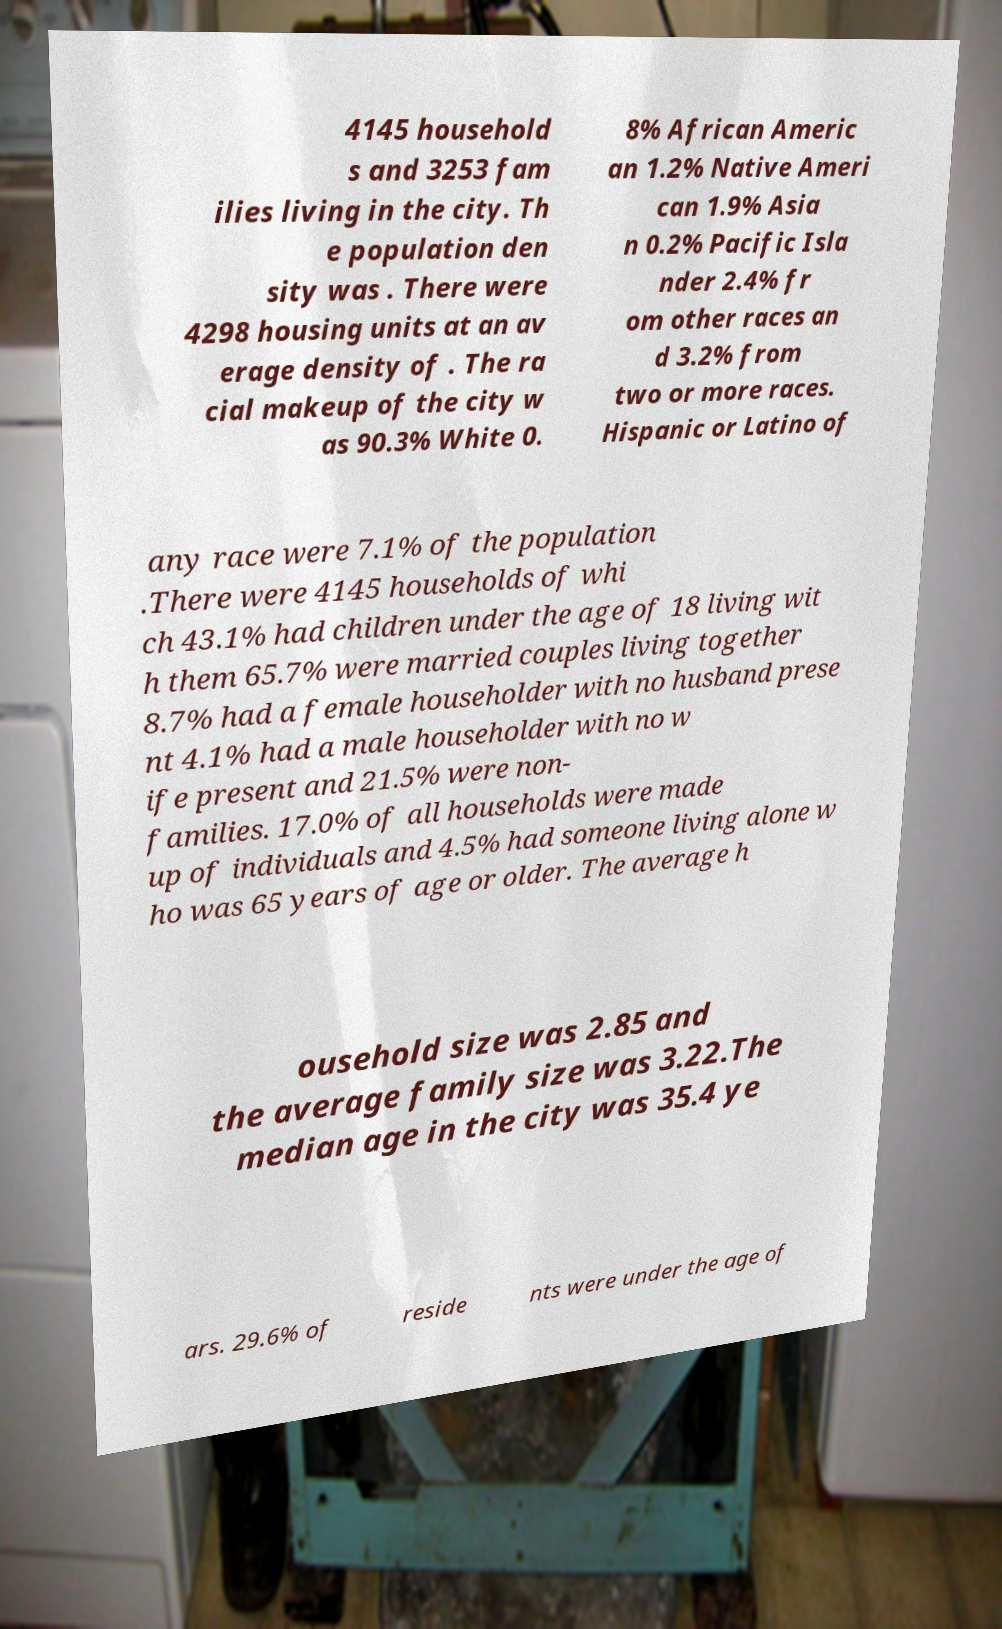What messages or text are displayed in this image? I need them in a readable, typed format. 4145 household s and 3253 fam ilies living in the city. Th e population den sity was . There were 4298 housing units at an av erage density of . The ra cial makeup of the city w as 90.3% White 0. 8% African Americ an 1.2% Native Ameri can 1.9% Asia n 0.2% Pacific Isla nder 2.4% fr om other races an d 3.2% from two or more races. Hispanic or Latino of any race were 7.1% of the population .There were 4145 households of whi ch 43.1% had children under the age of 18 living wit h them 65.7% were married couples living together 8.7% had a female householder with no husband prese nt 4.1% had a male householder with no w ife present and 21.5% were non- families. 17.0% of all households were made up of individuals and 4.5% had someone living alone w ho was 65 years of age or older. The average h ousehold size was 2.85 and the average family size was 3.22.The median age in the city was 35.4 ye ars. 29.6% of reside nts were under the age of 